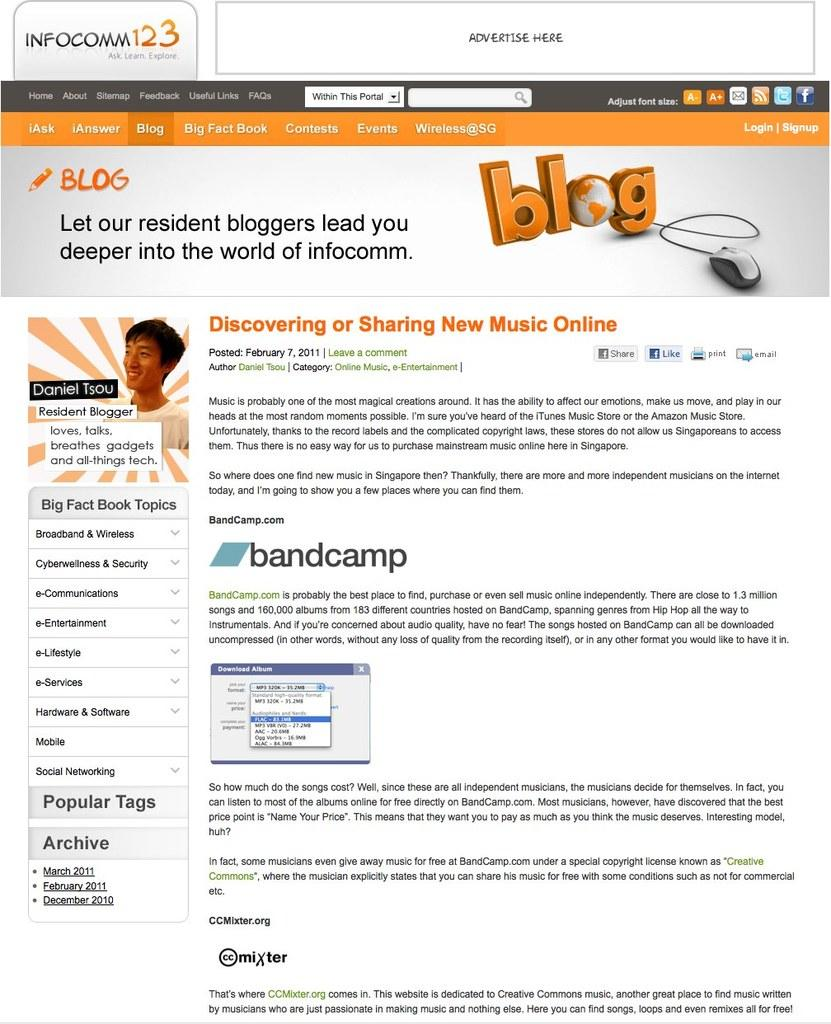What type of page is shown in the image? The image is of a blog's homepage. What can be seen representing the blog in the image? There is a logo of the blog in the image. What information is provided about the blog in the image? There is some text and description about the blog in the image. What type of lettuce is used in the blog's logo? There is no lettuce present in the image, as it is a blog's homepage with a logo and text. How many rings are visible in the image? There are no rings visible in the image; it features a blog's homepage with a logo and text. 